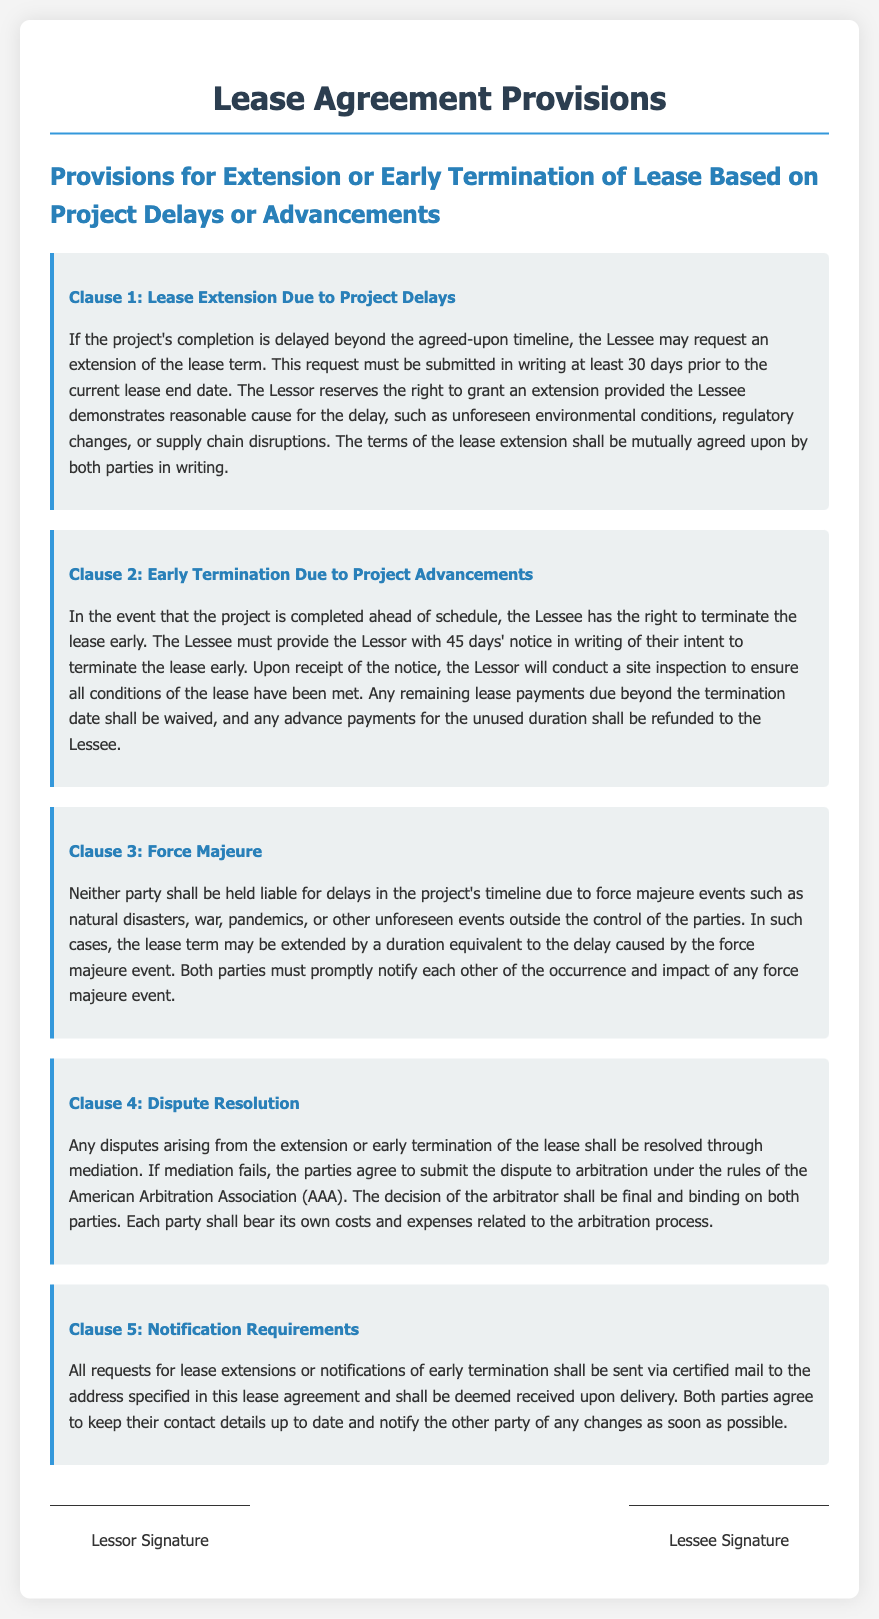What is the notice period for early termination? The Lessee must provide the Lessor with 45 days' notice in writing of their intent to terminate the lease early.
Answer: 45 days What must the Lessee demonstrate for a lease extension? The Lessee must demonstrate reasonable cause for the delay, such as unforeseen environmental conditions, regulatory changes, or supply chain disruptions.
Answer: Reasonable cause What is the timeframe for submitting a lease extension request? The request must be submitted in writing at least 30 days prior to the current lease end date.
Answer: 30 days What event can lead to waiving remaining lease payments? Any remaining lease payments due beyond the termination date shall be waived when the Lessee terminates the lease early.
Answer: Early termination Who conducts the site inspection upon early termination notice? The Lessor will conduct a site inspection to ensure all conditions of the lease have been met.
Answer: The Lessor What is the method for notifying lease changes? All requests for lease extensions or notifications of early termination shall be sent via certified mail.
Answer: Certified mail Which clause provides details on handling unforeseen circumstances? Clause 3: Force Majeure details how delays caused by unforeseen events are handled.
Answer: Force Majeure What is the final resolution method for disputes? The decision of the arbitrator shall be final and binding on both parties.
Answer: Arbitration 